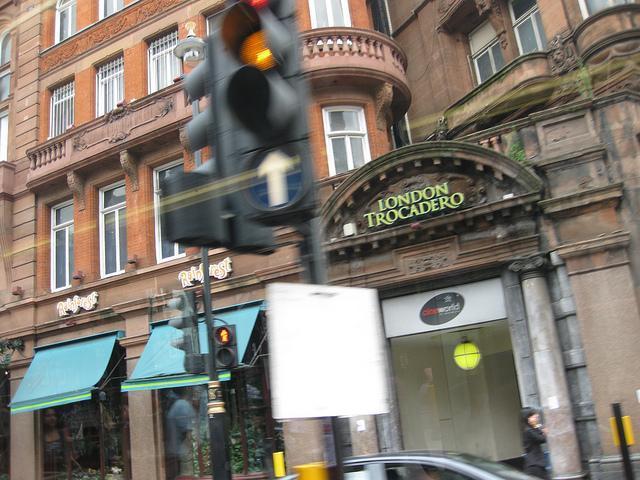How many traffic lights are in the picture?
Give a very brief answer. 2. 